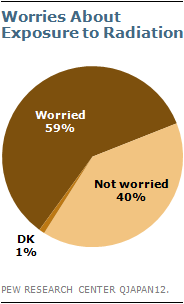Give some essential details in this illustration. In the survey, 40% of respondents indicated that they are not worried about exposure to radiation. The ratio of the "Not worried" segment to the sum of the largest and smallest segments is approximately 0.085416667... 